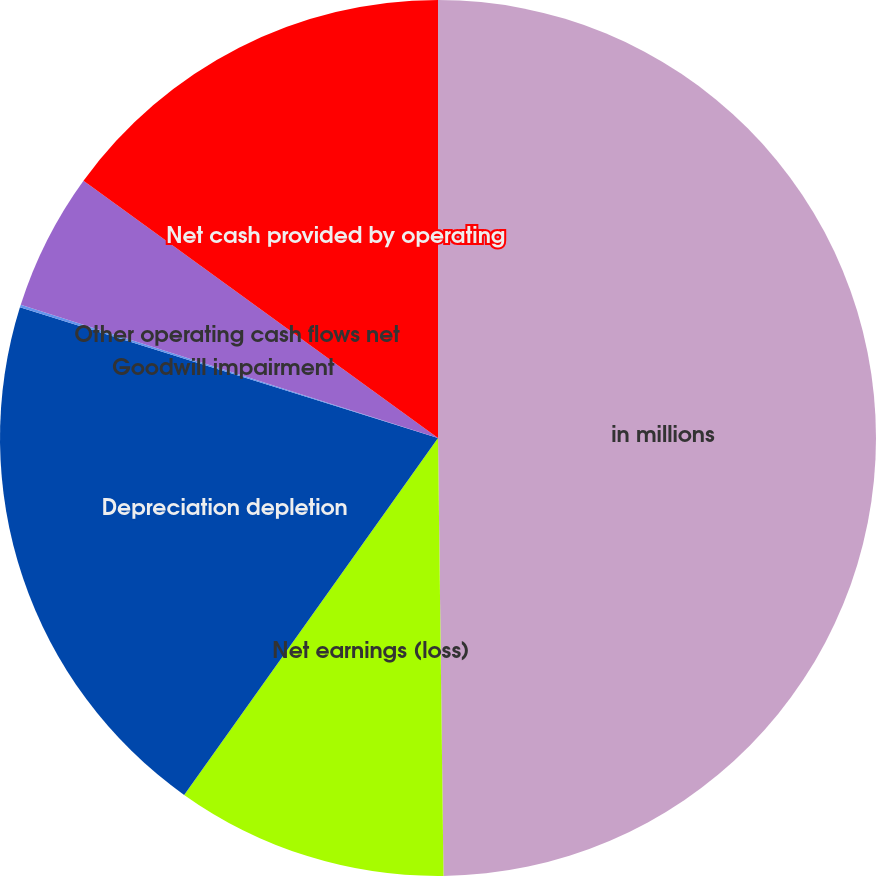<chart> <loc_0><loc_0><loc_500><loc_500><pie_chart><fcel>in millions<fcel>Net earnings (loss)<fcel>Depreciation depletion<fcel>Goodwill impairment<fcel>Other operating cash flows net<fcel>Net cash provided by operating<nl><fcel>49.8%<fcel>10.04%<fcel>19.98%<fcel>0.1%<fcel>5.07%<fcel>15.01%<nl></chart> 